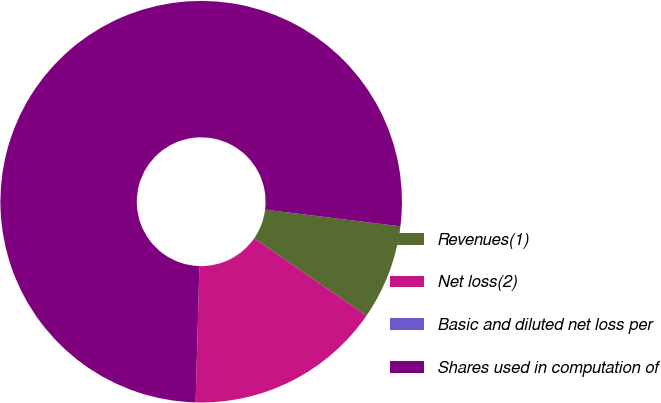Convert chart to OTSL. <chart><loc_0><loc_0><loc_500><loc_500><pie_chart><fcel>Revenues(1)<fcel>Net loss(2)<fcel>Basic and diluted net loss per<fcel>Shares used in computation of<nl><fcel>7.65%<fcel>15.83%<fcel>0.0%<fcel>76.51%<nl></chart> 